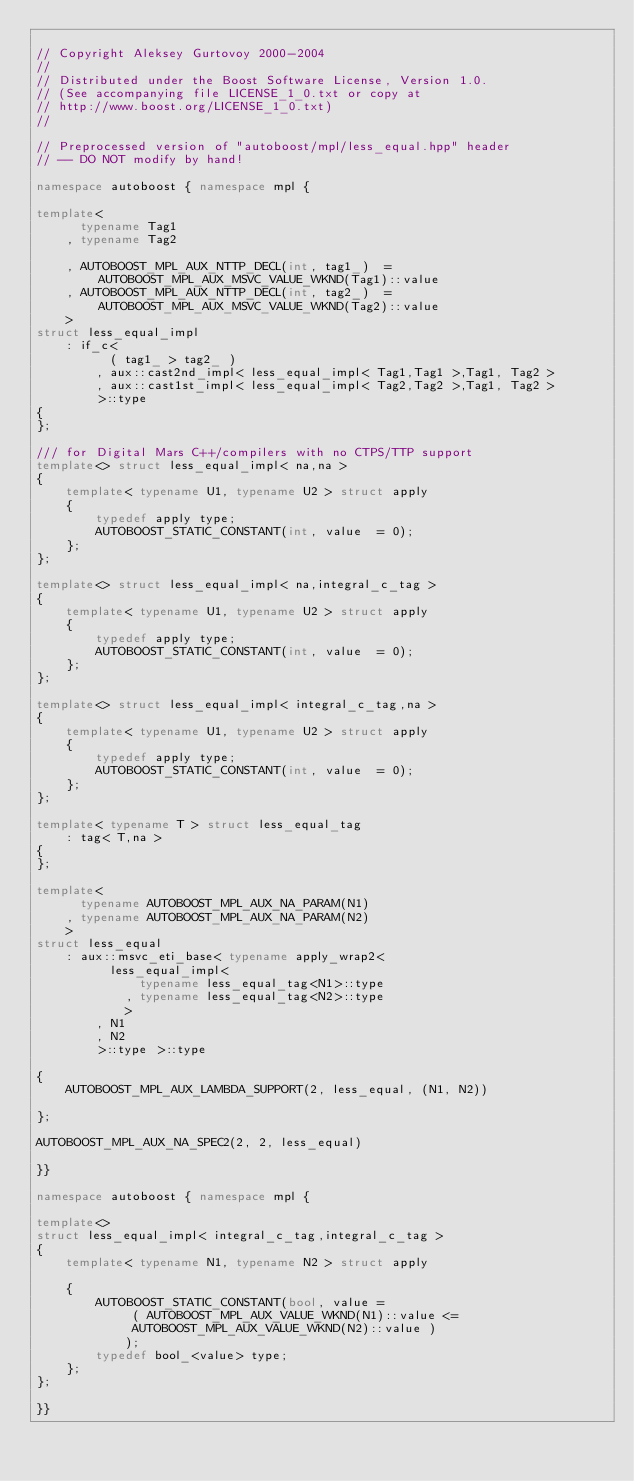<code> <loc_0><loc_0><loc_500><loc_500><_C++_>
// Copyright Aleksey Gurtovoy 2000-2004
//
// Distributed under the Boost Software License, Version 1.0.
// (See accompanying file LICENSE_1_0.txt or copy at
// http://www.boost.org/LICENSE_1_0.txt)
//

// Preprocessed version of "autoboost/mpl/less_equal.hpp" header
// -- DO NOT modify by hand!

namespace autoboost { namespace mpl {

template<
      typename Tag1
    , typename Tag2

    , AUTOBOOST_MPL_AUX_NTTP_DECL(int, tag1_)  = AUTOBOOST_MPL_AUX_MSVC_VALUE_WKND(Tag1)::value
    , AUTOBOOST_MPL_AUX_NTTP_DECL(int, tag2_)  = AUTOBOOST_MPL_AUX_MSVC_VALUE_WKND(Tag2)::value
    >
struct less_equal_impl
    : if_c<
          ( tag1_ > tag2_ )
        , aux::cast2nd_impl< less_equal_impl< Tag1,Tag1 >,Tag1, Tag2 >
        , aux::cast1st_impl< less_equal_impl< Tag2,Tag2 >,Tag1, Tag2 >
        >::type
{
};

/// for Digital Mars C++/compilers with no CTPS/TTP support
template<> struct less_equal_impl< na,na >
{
    template< typename U1, typename U2 > struct apply
    {
        typedef apply type;
        AUTOBOOST_STATIC_CONSTANT(int, value  = 0);
    };
};

template<> struct less_equal_impl< na,integral_c_tag >
{
    template< typename U1, typename U2 > struct apply
    {
        typedef apply type;
        AUTOBOOST_STATIC_CONSTANT(int, value  = 0);
    };
};

template<> struct less_equal_impl< integral_c_tag,na >
{
    template< typename U1, typename U2 > struct apply
    {
        typedef apply type;
        AUTOBOOST_STATIC_CONSTANT(int, value  = 0);
    };
};

template< typename T > struct less_equal_tag
    : tag< T,na >
{
};

template<
      typename AUTOBOOST_MPL_AUX_NA_PARAM(N1)
    , typename AUTOBOOST_MPL_AUX_NA_PARAM(N2)
    >
struct less_equal
    : aux::msvc_eti_base< typename apply_wrap2<
          less_equal_impl<
              typename less_equal_tag<N1>::type
            , typename less_equal_tag<N2>::type
            >
        , N1
        , N2
        >::type >::type

{
    AUTOBOOST_MPL_AUX_LAMBDA_SUPPORT(2, less_equal, (N1, N2))

};

AUTOBOOST_MPL_AUX_NA_SPEC2(2, 2, less_equal)

}}

namespace autoboost { namespace mpl {

template<>
struct less_equal_impl< integral_c_tag,integral_c_tag >
{
    template< typename N1, typename N2 > struct apply

    {
        AUTOBOOST_STATIC_CONSTANT(bool, value =
             ( AUTOBOOST_MPL_AUX_VALUE_WKND(N1)::value <=
             AUTOBOOST_MPL_AUX_VALUE_WKND(N2)::value )
            );
        typedef bool_<value> type;
    };
};

}}
</code> 